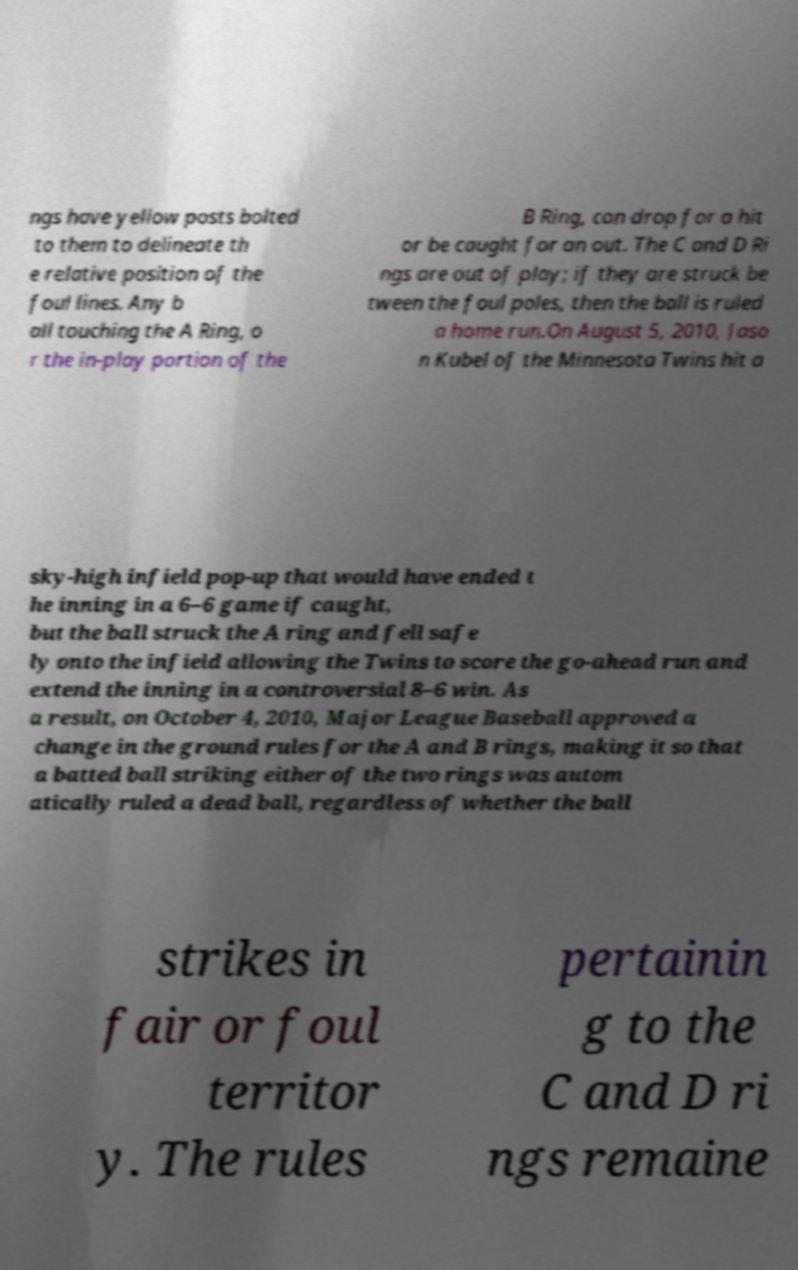There's text embedded in this image that I need extracted. Can you transcribe it verbatim? ngs have yellow posts bolted to them to delineate th e relative position of the foul lines. Any b all touching the A Ring, o r the in-play portion of the B Ring, can drop for a hit or be caught for an out. The C and D Ri ngs are out of play; if they are struck be tween the foul poles, then the ball is ruled a home run.On August 5, 2010, Jaso n Kubel of the Minnesota Twins hit a sky-high infield pop-up that would have ended t he inning in a 6–6 game if caught, but the ball struck the A ring and fell safe ly onto the infield allowing the Twins to score the go-ahead run and extend the inning in a controversial 8–6 win. As a result, on October 4, 2010, Major League Baseball approved a change in the ground rules for the A and B rings, making it so that a batted ball striking either of the two rings was autom atically ruled a dead ball, regardless of whether the ball strikes in fair or foul territor y. The rules pertainin g to the C and D ri ngs remaine 